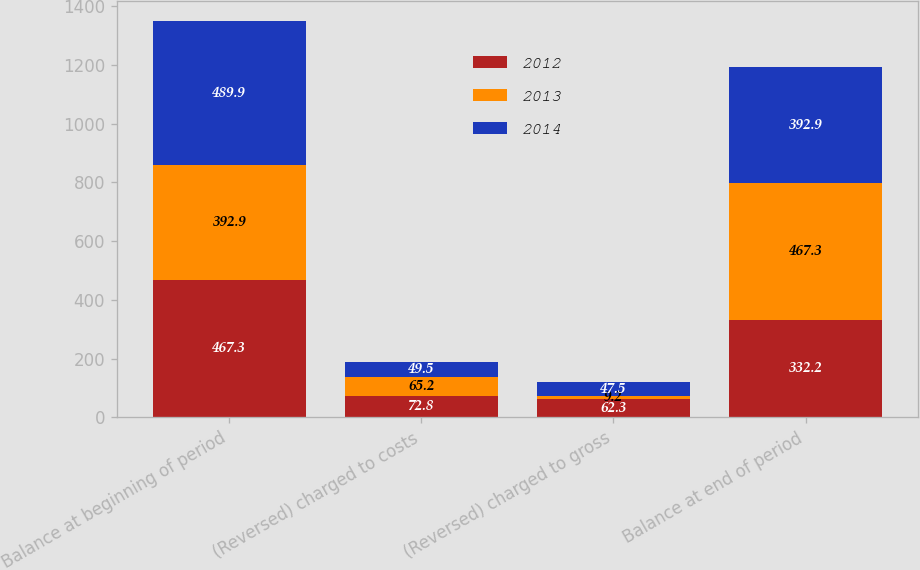<chart> <loc_0><loc_0><loc_500><loc_500><stacked_bar_chart><ecel><fcel>Balance at beginning of period<fcel>(Reversed) charged to costs<fcel>(Reversed) charged to gross<fcel>Balance at end of period<nl><fcel>2012<fcel>467.3<fcel>72.8<fcel>62.3<fcel>332.2<nl><fcel>2013<fcel>392.9<fcel>65.2<fcel>9.2<fcel>467.3<nl><fcel>2014<fcel>489.9<fcel>49.5<fcel>47.5<fcel>392.9<nl></chart> 